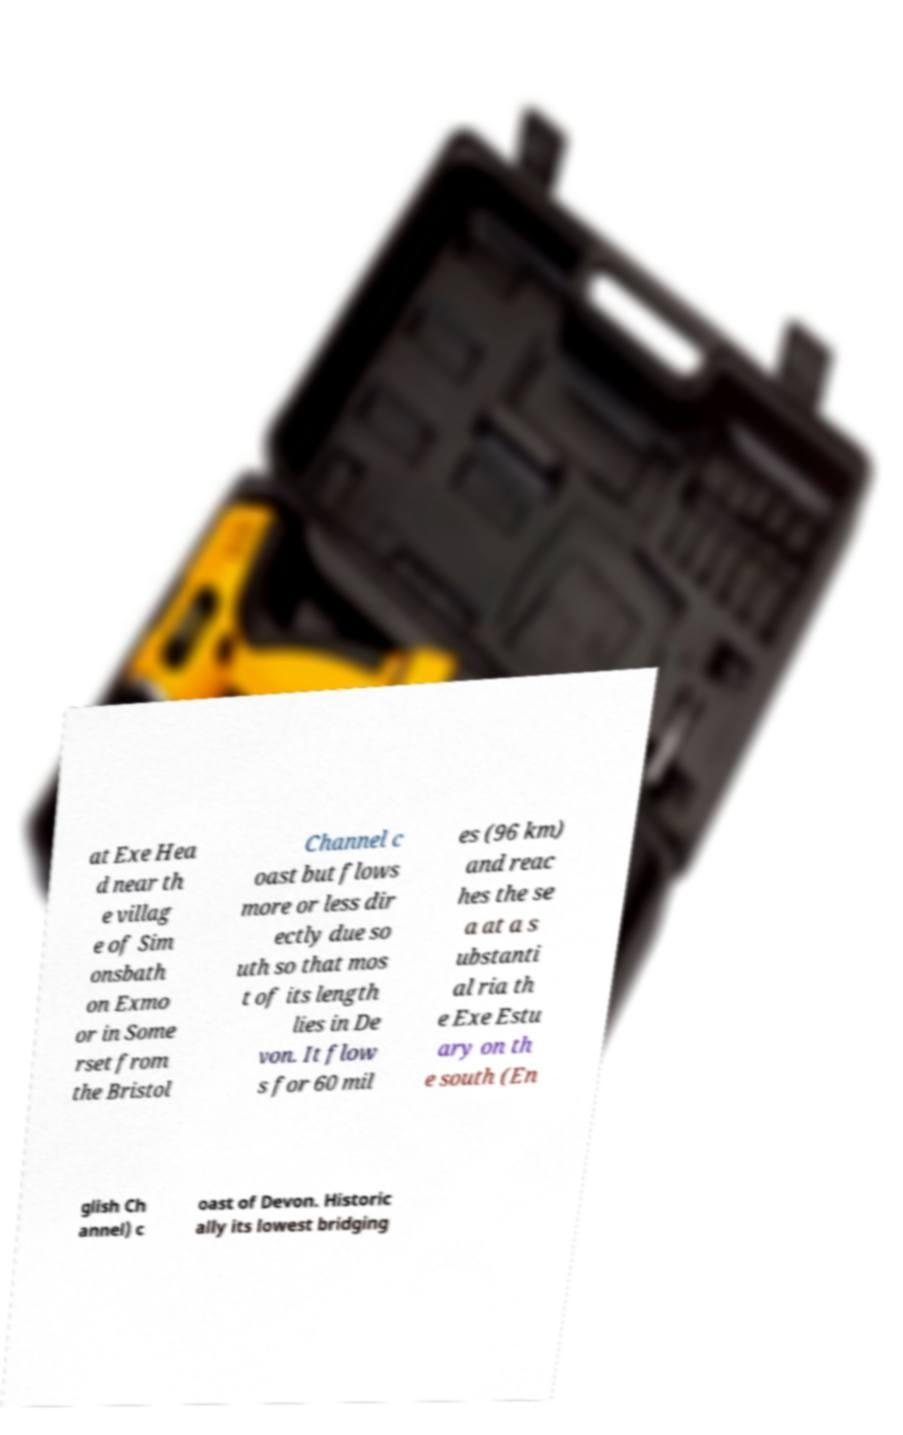Can you accurately transcribe the text from the provided image for me? at Exe Hea d near th e villag e of Sim onsbath on Exmo or in Some rset from the Bristol Channel c oast but flows more or less dir ectly due so uth so that mos t of its length lies in De von. It flow s for 60 mil es (96 km) and reac hes the se a at a s ubstanti al ria th e Exe Estu ary on th e south (En glish Ch annel) c oast of Devon. Historic ally its lowest bridging 